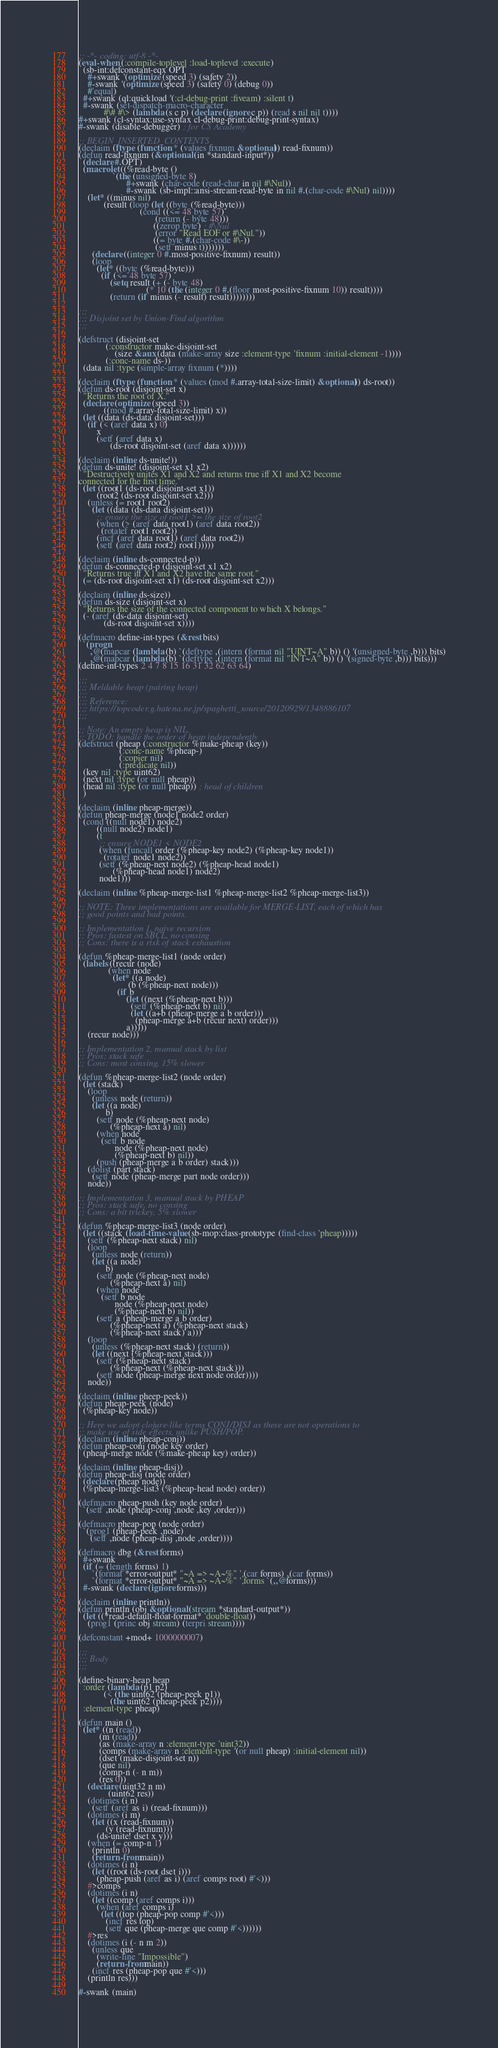Convert code to text. <code><loc_0><loc_0><loc_500><loc_500><_Lisp_>;; -*- coding: utf-8 -*-
(eval-when (:compile-toplevel :load-toplevel :execute)
  (sb-int:defconstant-eqx OPT
    #+swank '(optimize (speed 3) (safety 2))
    #-swank '(optimize (speed 3) (safety 0) (debug 0))
    #'equal)
  #+swank (ql:quickload '(:cl-debug-print :fiveam) :silent t)
  #-swank (set-dispatch-macro-character
           #\# #\> (lambda (s c p) (declare (ignore c p)) (read s nil nil t))))
#+swank (cl-syntax:use-syntax cl-debug-print:debug-print-syntax)
#-swank (disable-debugger) ; for CS Academy

;; BEGIN_INSERTED_CONTENTS
(declaim (ftype (function * (values fixnum &optional)) read-fixnum))
(defun read-fixnum (&optional (in *standard-input*))
  (declare #.OPT)
  (macrolet ((%read-byte ()
               `(the (unsigned-byte 8)
                     #+swank (char-code (read-char in nil #\Nul))
                     #-swank (sb-impl::ansi-stream-read-byte in nil #.(char-code #\Nul) nil))))
    (let* ((minus nil)
           (result (loop (let ((byte (%read-byte)))
                           (cond ((<= 48 byte 57)
                                  (return (- byte 48)))
                                 ((zerop byte) ; #\Nul
                                  (error "Read EOF or #\Nul."))
                                 ((= byte #.(char-code #\-))
                                  (setf minus t)))))))
      (declare ((integer 0 #.most-positive-fixnum) result))
      (loop
        (let* ((byte (%read-byte)))
          (if (<= 48 byte 57)
              (setq result (+ (- byte 48)
                              (* 10 (the (integer 0 #.(floor most-positive-fixnum 10)) result))))
              (return (if minus (- result) result))))))))

;;;
;;; Disjoint set by Union-Find algorithm
;;;

(defstruct (disjoint-set
            (:constructor make-disjoint-set
                (size &aux (data (make-array size :element-type 'fixnum :initial-element -1))))
            (:conc-name ds-))
  (data nil :type (simple-array fixnum (*))))

(declaim (ftype (function * (values (mod #.array-total-size-limit) &optional)) ds-root))
(defun ds-root (disjoint-set x)
  "Returns the root of X."
  (declare (optimize (speed 3))
           ((mod #.array-total-size-limit) x))
  (let ((data (ds-data disjoint-set)))
    (if (< (aref data x) 0)
        x
        (setf (aref data x)
              (ds-root disjoint-set (aref data x))))))

(declaim (inline ds-unite!))
(defun ds-unite! (disjoint-set x1 x2)
  "Destructively unites X1 and X2 and returns true iff X1 and X2 become
connected for the first time."
  (let ((root1 (ds-root disjoint-set x1))
        (root2 (ds-root disjoint-set x2)))
    (unless (= root1 root2)
      (let ((data (ds-data disjoint-set)))
        ;; ensure the size of root1 >= the size of root2
        (when (> (aref data root1) (aref data root2))
          (rotatef root1 root2))
        (incf (aref data root1) (aref data root2))
        (setf (aref data root2) root1)))))

(declaim (inline ds-connected-p))
(defun ds-connected-p (disjoint-set x1 x2)
  "Returns true iff X1 and X2 have the same root."
  (= (ds-root disjoint-set x1) (ds-root disjoint-set x2)))

(declaim (inline ds-size))
(defun ds-size (disjoint-set x)
  "Returns the size of the connected component to which X belongs."
  (- (aref (ds-data disjoint-set)
           (ds-root disjoint-set x))))

(defmacro define-int-types (&rest bits)
  `(progn
     ,@(mapcar (lambda (b) `(deftype ,(intern (format nil "UINT~A" b)) () '(unsigned-byte ,b))) bits)
     ,@(mapcar (lambda (b) `(deftype ,(intern (format nil "INT~A" b)) () '(signed-byte ,b))) bits)))
(define-int-types 2 4 7 8 15 16 31 32 62 63 64)

;;;
;;; Meldable heap (pairing heap)
;;;
;;; Reference:
;;; https://topcoder.g.hatena.ne.jp/spaghetti_source/20120929/1348886107
;;;

;; Note: An empty heap is NIL.
;; TODO: handle the order of heap independently
(defstruct (pheap (:constructor %make-pheap (key))
                  (:conc-name %pheap-)
                  (:copier nil)
                  (:predicate nil))
  (key nil :type uint62)
  (next nil :type (or null pheap))
  (head nil :type (or null pheap)) ; head of children
  )

(declaim (inline pheap-merge))
(defun pheap-merge (node1 node2 order)
  (cond ((null node1) node2)
        ((null node2) node1)
        (t
         ;; ensure NODE1 < NODE2
         (when (funcall order (%pheap-key node2) (%pheap-key node1))
           (rotatef node1 node2))
         (setf (%pheap-next node2) (%pheap-head node1)
               (%pheap-head node1) node2)
         node1)))

(declaim (inline %pheap-merge-list1 %pheap-merge-list2 %pheap-merge-list3))

;; NOTE: Three implementations are available for MERGE-LIST, each of which has
;; good points and bad points.

;; Implementation 1, naive recursion
;; Pros: fastest on SBCL, no consing
;; Cons: there is a risk of stack exhaustion

(defun %pheap-merge-list1 (node order)
  (labels ((recur (node)
             (when node
               (let* ((a node)
                      (b (%pheap-next node)))
                 (if b
                     (let ((next (%pheap-next b)))
                       (setf (%pheap-next b) nil)
                       (let ((a+b (pheap-merge a b order)))
                         (pheap-merge a+b (recur next) order)))
                     a)))))
    (recur node)))

;; Implementation 2, manual stack by list
;; Pros: stack safe
;; Cons: most consing, 15% slower

(defun %pheap-merge-list2 (node order)
  (let (stack)
    (loop
      (unless node (return))
      (let ((a node)
            b)
        (setf node (%pheap-next node)
              (%pheap-next a) nil)
        (when node
          (setf b node
                node (%pheap-next node)
                (%pheap-next b) nil))
        (push (pheap-merge a b order) stack)))
    (dolist (part stack)
      (setf node (pheap-merge part node order)))
    node))

;; Implementation 3, manual stack by PHEAP
;; Pros: stack safe, no consing
;; Cons: a bit trickey, 5% slower

(defun %pheap-merge-list3 (node order)
  (let ((stack (load-time-value (sb-mop:class-prototype (find-class 'pheap)))))
    (setf (%pheap-next stack) nil)
    (loop
      (unless node (return))
      (let ((a node)
            b)
        (setf node (%pheap-next node)
              (%pheap-next a) nil)
        (when node
          (setf b node
                node (%pheap-next node)
                (%pheap-next b) nil))
        (setf a (pheap-merge a b order)
              (%pheap-next a) (%pheap-next stack)
              (%pheap-next stack) a)))
    (loop
      (unless (%pheap-next stack) (return))
      (let ((next (%pheap-next stack)))
        (setf (%pheap-next stack)
              (%pheap-next (%pheap-next stack)))
        (setf node (pheap-merge next node order))))
    node))

(declaim (inline pheep-peek))
(defun pheap-peek (node)
  (%pheap-key node))

;; Here we adopt clojure-like terms CONJ/DISJ as these are not operations to
;; make use of side effects, unlike PUSH/POP.
(declaim (inline pheap-conj))
(defun pheap-conj (node key order)
  (pheap-merge node (%make-pheap key) order))

(declaim (inline pheap-disj))
(defun pheap-disj (node order)
  (declare (pheap node))
  (%pheap-merge-list3 (%pheap-head node) order))

(defmacro pheap-push (key node order)
  `(setf ,node (pheap-conj ,node ,key ,order)))

(defmacro pheap-pop (node order)
  `(prog1 (pheap-peek ,node)
     (setf ,node (pheap-disj ,node ,order))))

(defmacro dbg (&rest forms)
  #+swank
  (if (= (length forms) 1)
      `(format *error-output* "~A => ~A~%" ',(car forms) ,(car forms))
      `(format *error-output* "~A => ~A~%" ',forms `(,,@forms)))
  #-swank (declare (ignore forms)))

(declaim (inline println))
(defun println (obj &optional (stream *standard-output*))
  (let ((*read-default-float-format* 'double-float))
    (prog1 (princ obj stream) (terpri stream))))

(defconstant +mod+ 1000000007)

;;;
;;; Body
;;;

(define-binary-heap heap
  :order (lambda (p1 p2)
           (< (the uint62 (pheap-peek p1))
              (the uint62 (pheap-peek p2))))
  :element-type pheap)

(defun main ()
  (let* ((n (read))
         (m (read))
         (as (make-array n :element-type 'uint32))
         (comps (make-array n :element-type '(or null pheap) :initial-element nil))
         (dset (make-disjoint-set n))
         (que nil)
         (comp-n (- n m))
         (res 0))
    (declare (uint32 n m)
             (uint62 res))
    (dotimes (i n)
      (setf (aref as i) (read-fixnum)))
    (dotimes (i m)
      (let ((x (read-fixnum))
            (y (read-fixnum)))
        (ds-unite! dset x y)))
    (when (= comp-n 1)
      (println 0)
      (return-from main))
    (dotimes (i n)
      (let ((root (ds-root dset i)))
        (pheap-push (aref as i) (aref comps root) #'<)))
    #>comps
    (dotimes (i n)
      (let ((comp (aref comps i)))
        (when (aref comps i)
          (let ((top (pheap-pop comp #'<)))
            (incf res top)
            (setf que (pheap-merge que comp #'<))))))
    #>res
    (dotimes (i (- n m 2))
      (unless que
        (write-line "Impossible")
        (return-from main))
      (incf res (pheap-pop que #'<)))
    (println res)))

#-swank (main)
</code> 